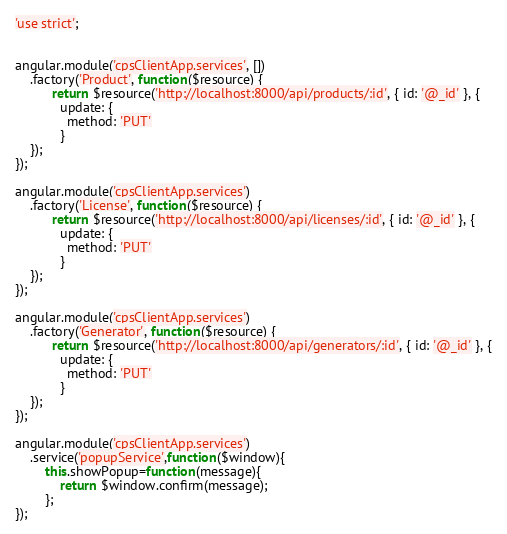<code> <loc_0><loc_0><loc_500><loc_500><_JavaScript_>'use strict';


angular.module('cpsClientApp.services', [])
	.factory('Product', function($resource) {
		  return $resource('http://localhost:8000/api/products/:id', { id: '@_id' }, {
		    update: {
		      method: 'PUT'
		    }
	});
});

angular.module('cpsClientApp.services')
	.factory('License', function($resource) {
		  return $resource('http://localhost:8000/api/licenses/:id', { id: '@_id' }, {
		    update: {
		      method: 'PUT'
		    }
	});
});

angular.module('cpsClientApp.services')
	.factory('Generator', function($resource) {
		  return $resource('http://localhost:8000/api/generators/:id', { id: '@_id' }, {
		    update: {
		      method: 'PUT'
		    }
	});
});

angular.module('cpsClientApp.services')
	.service('popupService',function($window){
	    this.showPopup=function(message){
	        return $window.confirm(message);
	    };
});</code> 